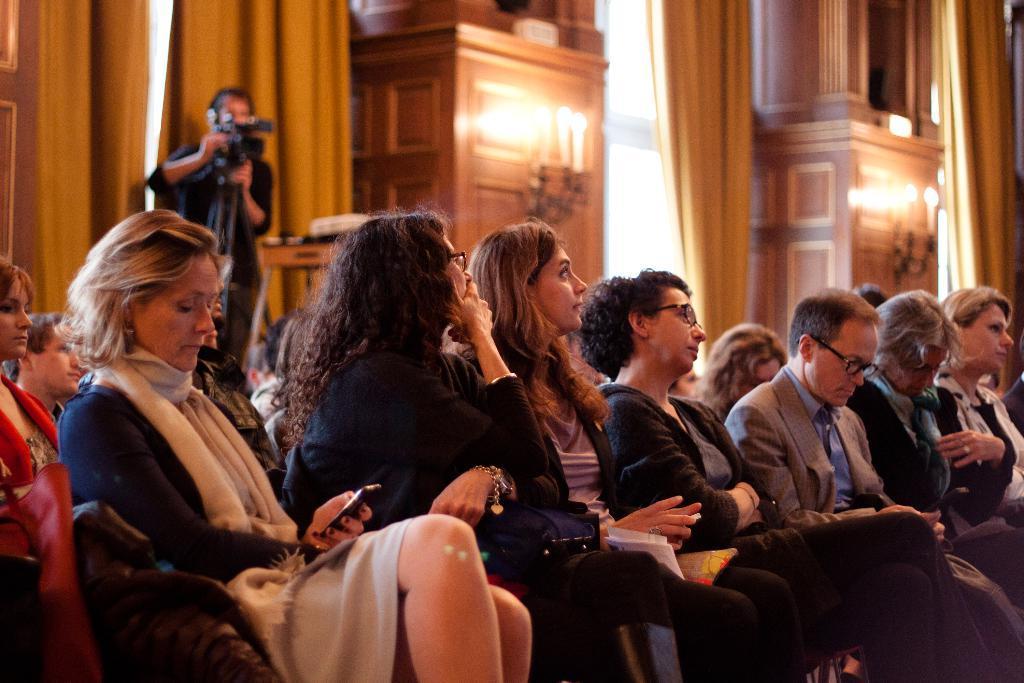Please provide a concise description of this image. In this image, we can see a group of people wearing clothes. There is a person on the left side of the image holding a camera with his hands and standing in front of curtains. There are candles at the top of the image. 